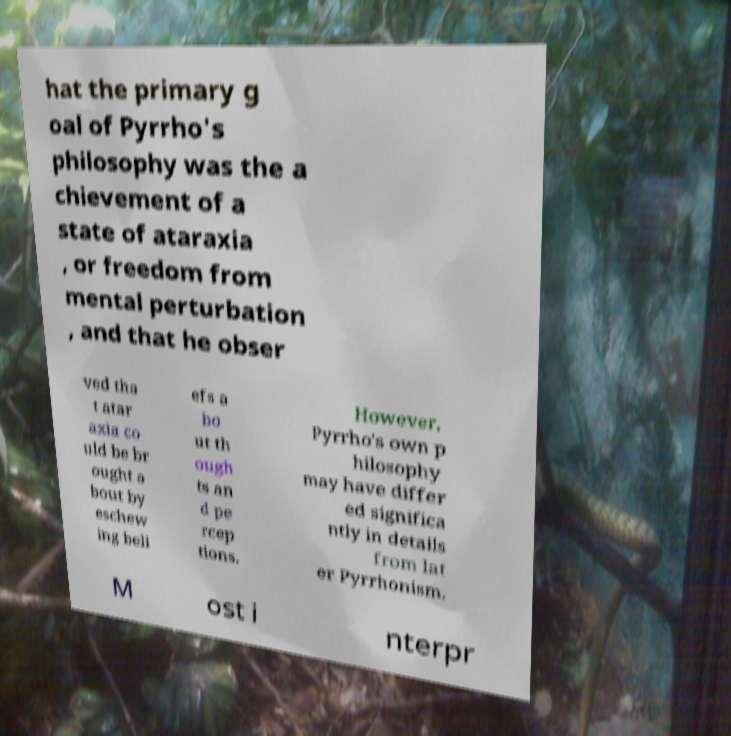Please read and relay the text visible in this image. What does it say? hat the primary g oal of Pyrrho's philosophy was the a chievement of a state of ataraxia , or freedom from mental perturbation , and that he obser ved tha t atar axia co uld be br ought a bout by eschew ing beli efs a bo ut th ough ts an d pe rcep tions. However, Pyrrho's own p hilosophy may have differ ed significa ntly in details from lat er Pyrrhonism. M ost i nterpr 